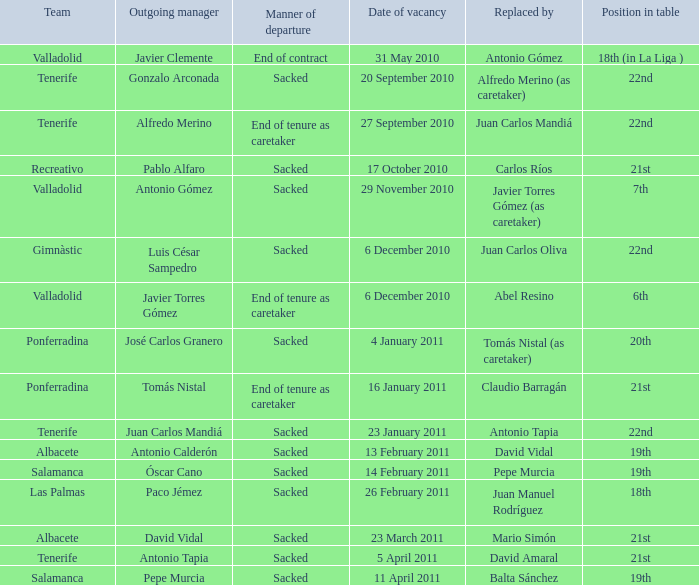What was the position of appointment date 17 january 2011 21st. 